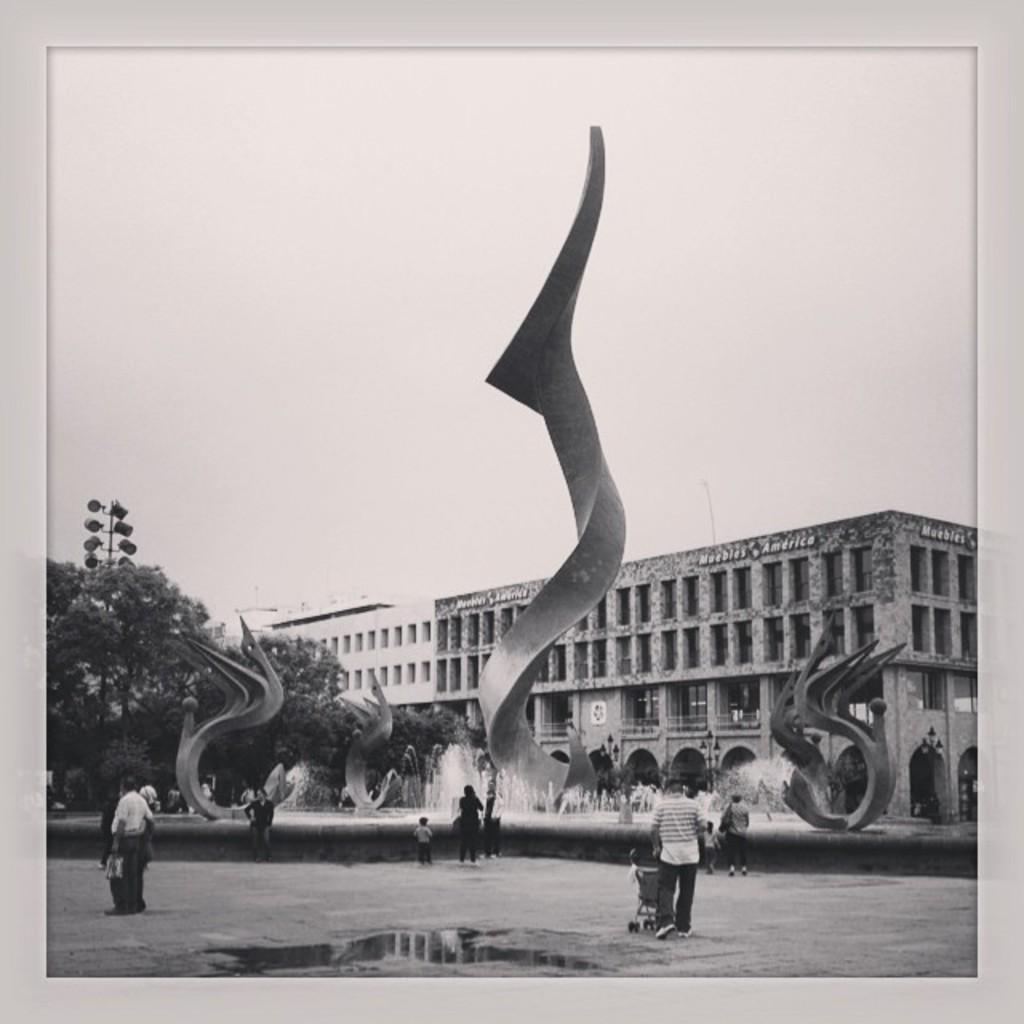In one or two sentences, can you explain what this image depicts? In this image we can see few people on the road, there is a fountain, few statues, trees, a pole with lights, a building and the sky in the background. 